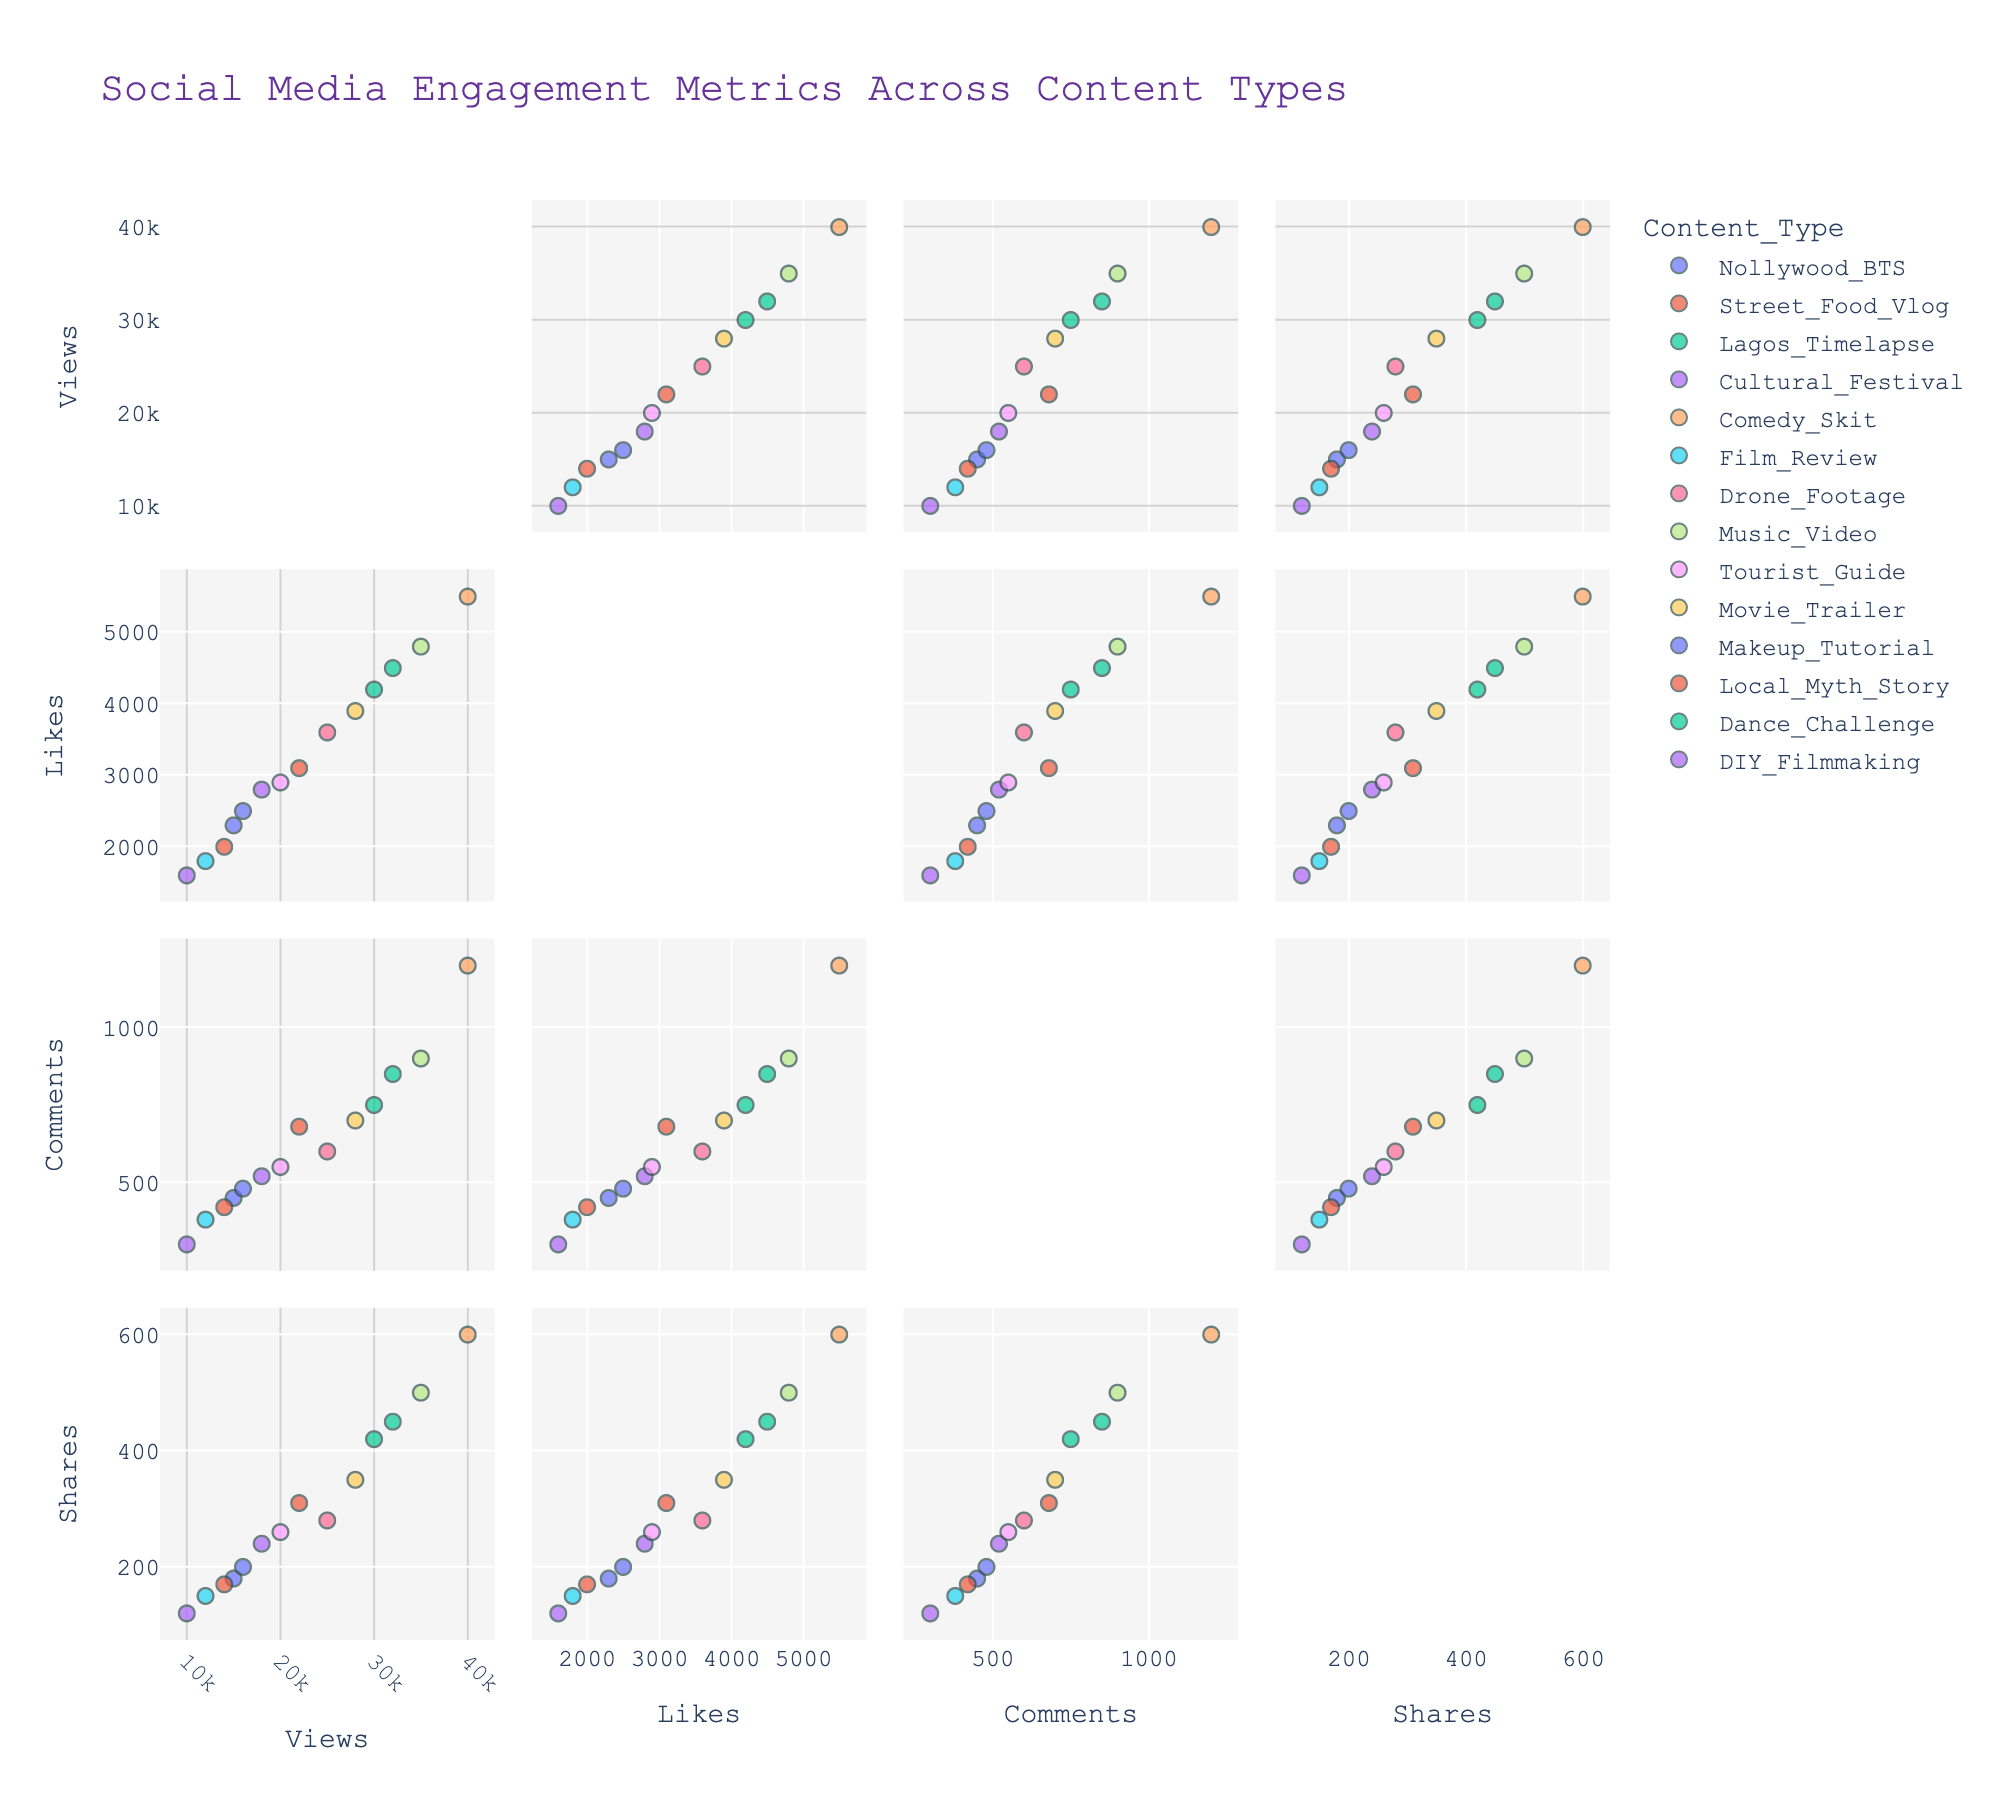What's the title of the figure? Look at the top of the figure to find the text that describes the entire plot.
Answer: Social Media Engagement Metrics Across Content Types How many content types are displayed in the figure? Identify the different colors or markers used in the scatterplot matrix, each representing a unique content type.
Answer: 14 Which content type has the highest number of likes? Find the point with the highest 'Likes' value and observe the corresponding content type.
Answer: Comedy Skit Between "Comedy Skit" and "Makeup Tutorial," which one has more comments on average? Compare the 'Comments' values for both content types and calculate their averages.
Answer: Comedy Skit What is the overall trend between views and shares? Observe the scatterplot of views versus shares and note if there's a positive or negative trend.
Answer: Positive trend Which content type shows the least engagement in terms of likes and comments? Look for the data point with the smallest values in both 'Likes' and 'Comments' dimensions and identify the corresponding content type.
Answer: DIY Filmmaking What is the posting time for the "Lagos Timelapse" content type? Identify the "Lagos Timelapse" data points and check the hover data or labels for posting time associated with it.
Answer: 19:00 Are the comments significantly correlated with shares for "Street Food Vlog"? Compare the comments and shares scatter for "Street Food Vlog." If the points form a noticeable linear pattern, they are significantly correlated.
Answer: Yes Which posting time appears most frequently among the content types with maximum likes? Identify content types with the highest likes and check their corresponding posting times. Count the frequency of each posting time.
Answer: Evening (After 18:00) Between "Nollywood BTS" and "Film Review," which content type has the higher discrepancy between likes and shares? Calculate the difference between likes and shares for both content types and compare them.
Answer: Nollywood BTS 